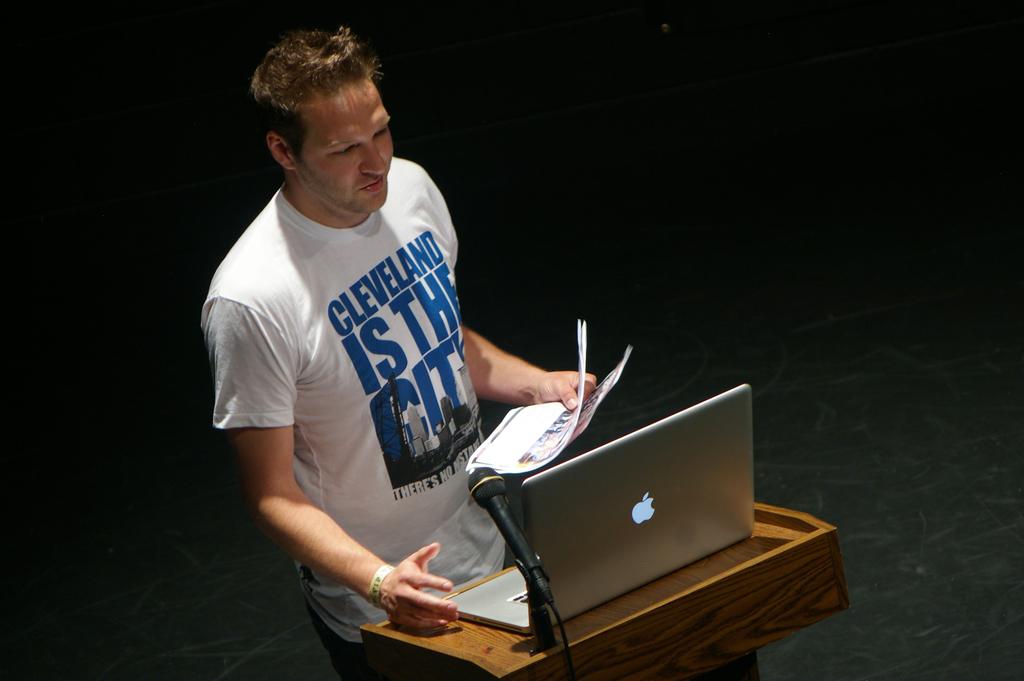What is the city?
Offer a very short reply. Cleveland. 